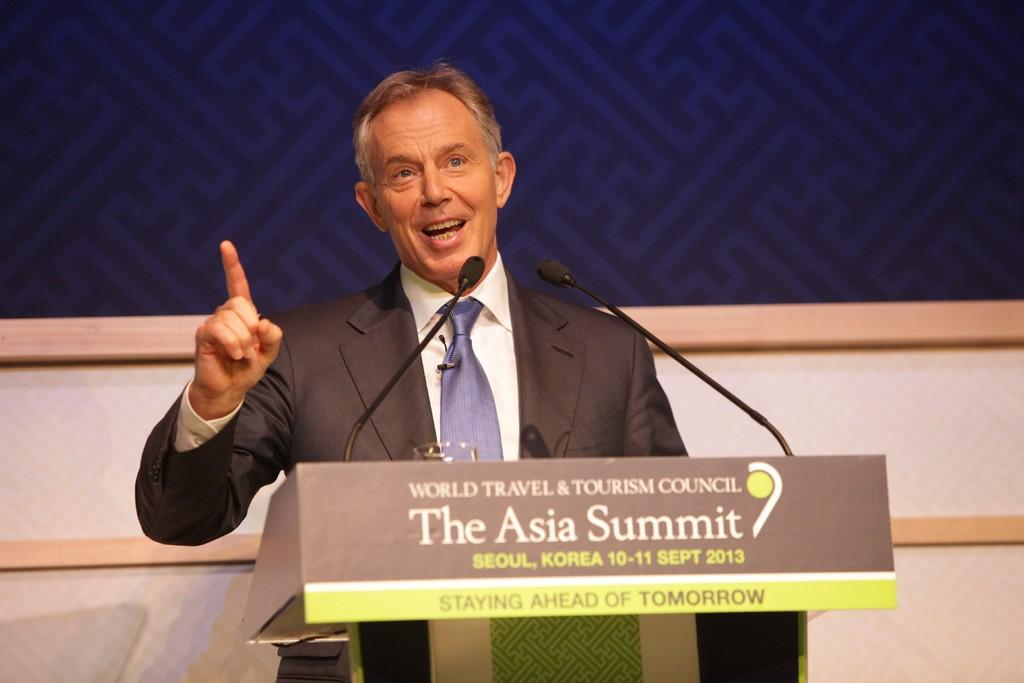What is the person in the image doing? There is a person standing in front of the podium. What can be seen on the podium? There are two microphones and a glass on the podium. What is visible behind the podium? The background appears to be a wall. What statement does the person's brain make in the image? There is no indication in the image that the person's brain is making a statement. 